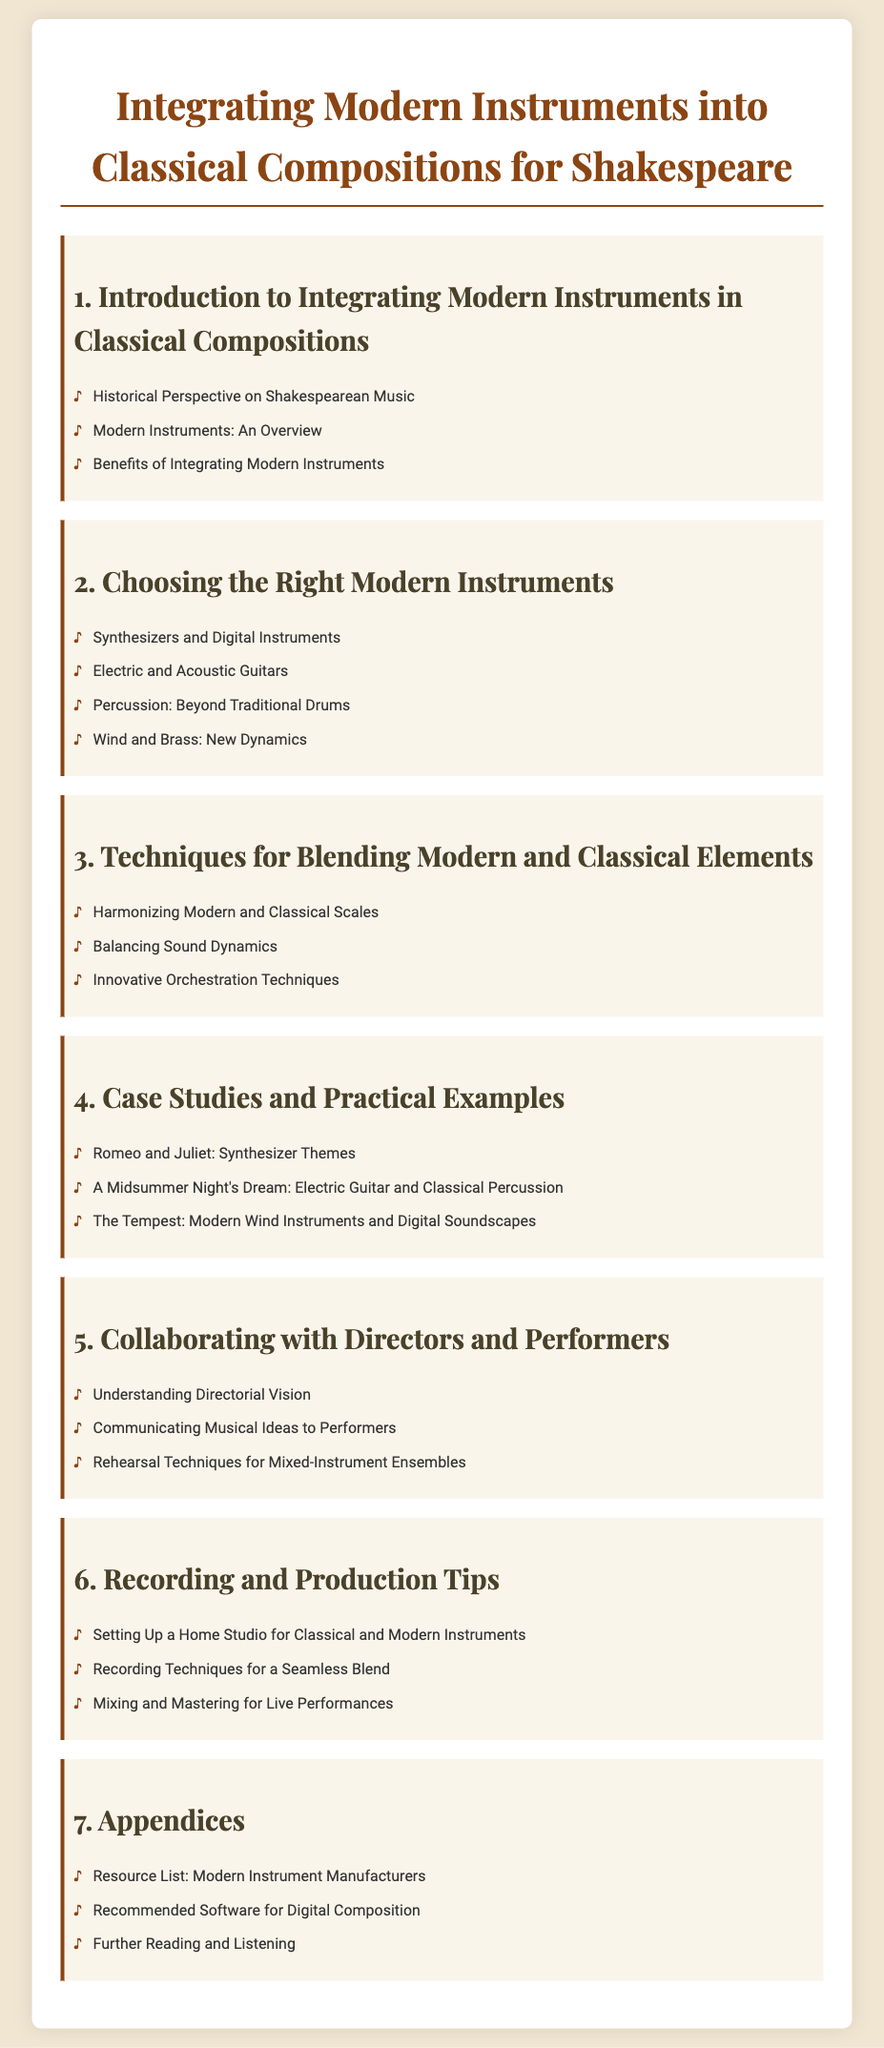What is the title of the document? The title is the main heading found at the top of the document.
Answer: Integrating Modern Instruments into Classical Compositions for Shakespeare What is the first chapter about? The first chapter's title indicates its focus on introducing the topic of modern instruments in classical compositions.
Answer: Introduction to Integrating Modern Instruments in Classical Compositions How many case studies are listed in chapter 4? The number of case studies can be determined by counting the list items under chapter 4.
Answer: Three What type of instruments are discussed in the second chapter? The title of the second chapter reveals its focus on selecting appropriate modern instruments for compositions.
Answer: Modern Instruments What important aspect does chapter 5 cover? The chapter title suggests it deals with working relationships necessary for musical collaboration.
Answer: Collaborating with Directors and Performers Which section includes a resource list? The appendices section is where additional materials and references are typically found.
Answer: Appendices What technique is listed under chapter 3? The list of techniques in chapter 3 includes methods for blending modern and classical components.
Answer: Harmonizing Modern and Classical Scales What kind of tools does chapter 6 discuss for musical work? The title of the chapter indicates it focuses on the technical aspects of recording and production.
Answer: Recording and Production Tips What color is used for the main chapter headings? The color designation can be inferred from the document's style for headings.
Answer: #4A412A 